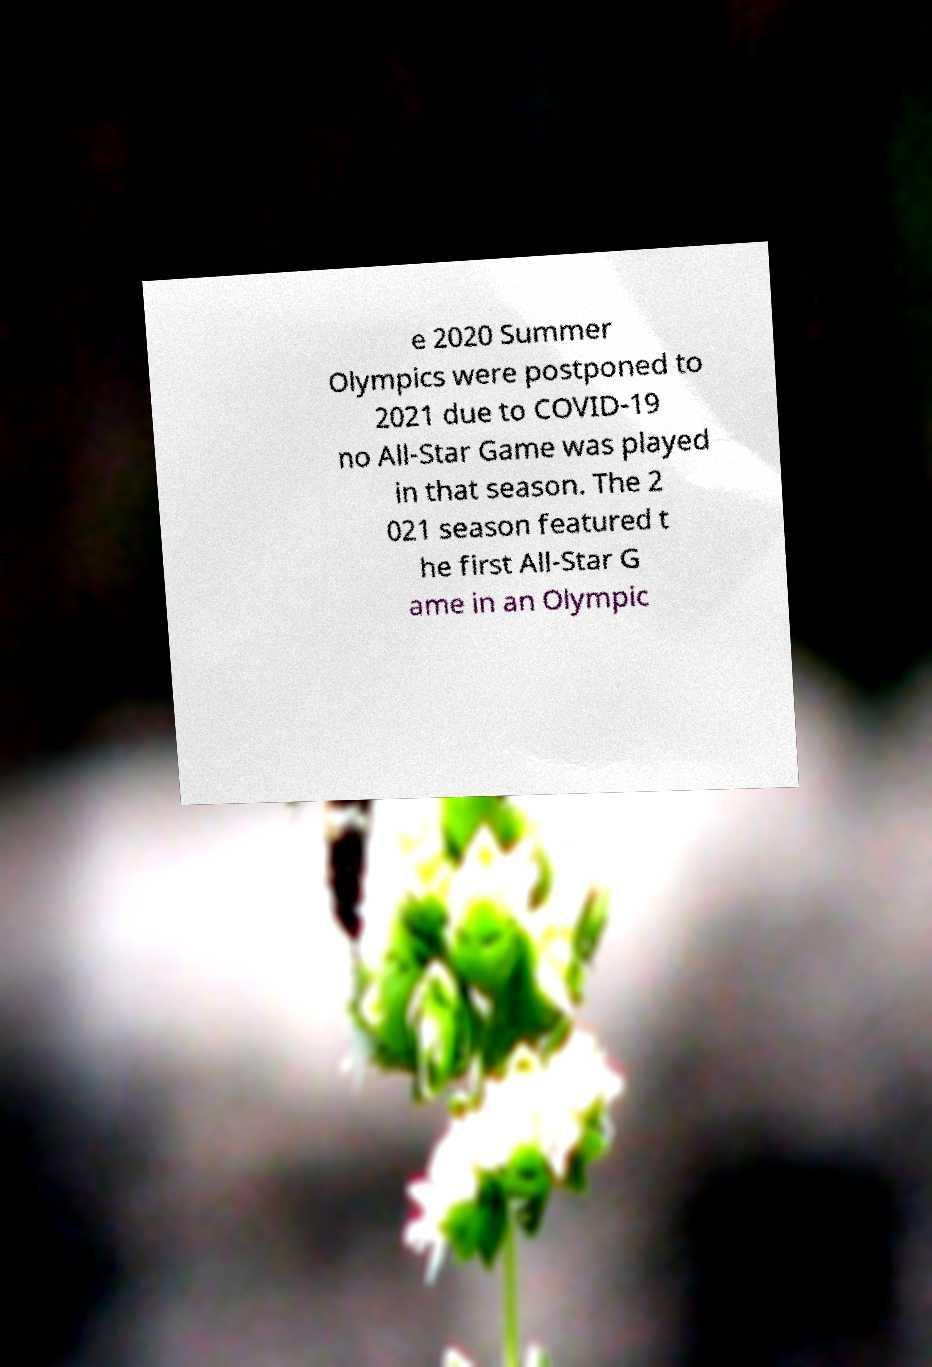Can you read and provide the text displayed in the image?This photo seems to have some interesting text. Can you extract and type it out for me? e 2020 Summer Olympics were postponed to 2021 due to COVID-19 no All-Star Game was played in that season. The 2 021 season featured t he first All-Star G ame in an Olympic 